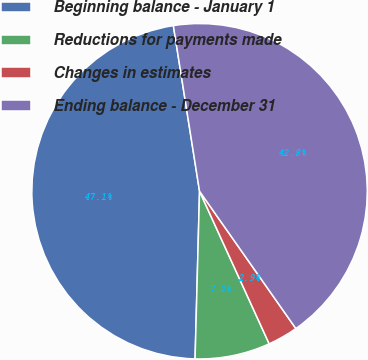Convert chart. <chart><loc_0><loc_0><loc_500><loc_500><pie_chart><fcel>Beginning balance - January 1<fcel>Reductions for payments made<fcel>Changes in estimates<fcel>Ending balance - December 31<nl><fcel>47.08%<fcel>7.24%<fcel>2.92%<fcel>42.76%<nl></chart> 